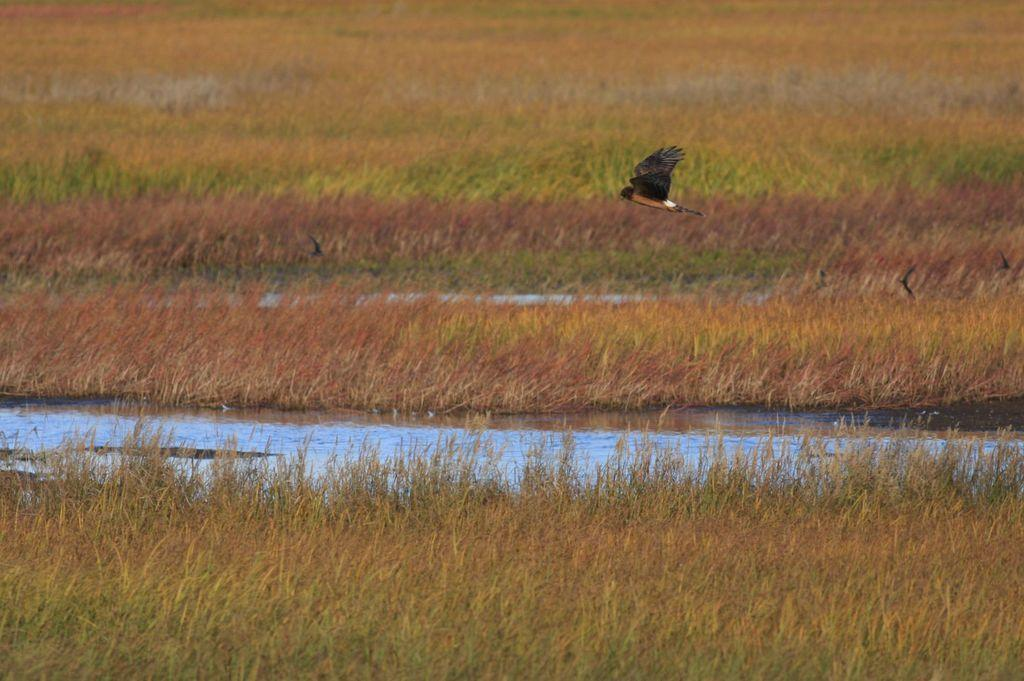What is the bird doing in the image? The bird is flying in the air. What can be seen below the bird in the image? There is water visible in the image. What type of landscape is visible in the background of the image? The background of the image includes grassland. What is the reaction of the bird when it sees the mouth in the image? There is no mouth present in the image, so the bird's reaction cannot be determined. 